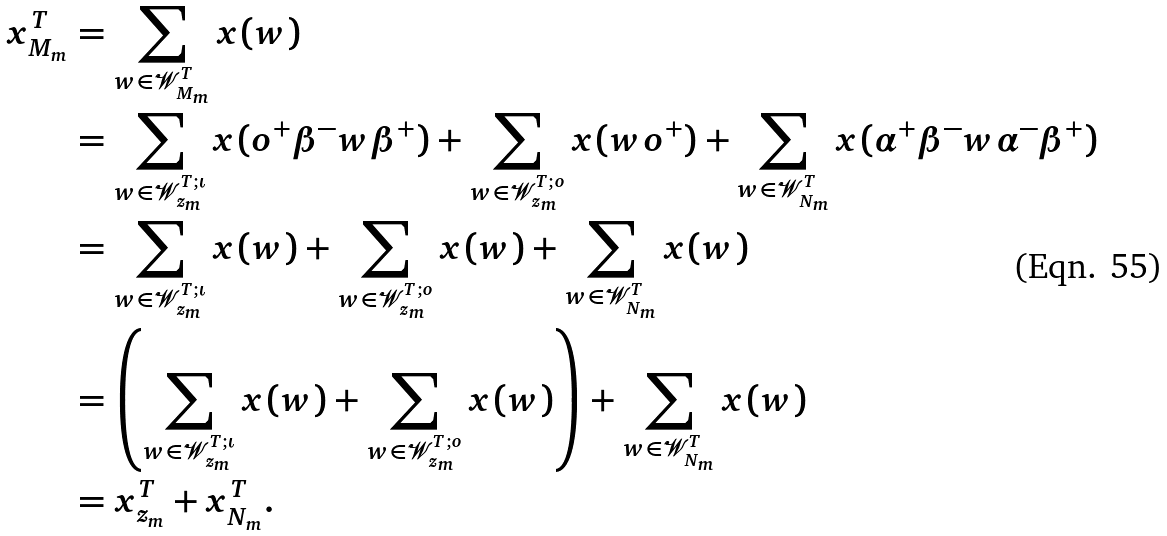Convert formula to latex. <formula><loc_0><loc_0><loc_500><loc_500>x ^ { T } _ { M _ { m } } & = \sum _ { w \in \mathcal { W } ^ { T } _ { M _ { m } } } x ( w ) \\ & = \sum _ { w \in \mathcal { W } ^ { T ; \iota } _ { z _ { m } } } x ( o ^ { + } \beta ^ { - } w \beta ^ { + } ) + \sum _ { w \in \mathcal { W } ^ { T ; o } _ { z _ { m } } } x ( w o ^ { + } ) + \sum _ { w \in \mathcal { W } ^ { T } _ { N _ { m } } } x ( \alpha ^ { + } \beta ^ { - } w \alpha ^ { - } \beta ^ { + } ) \\ & = \sum _ { w \in \mathcal { W } ^ { T ; \iota } _ { z _ { m } } } x ( w ) + \sum _ { w \in \mathcal { W } ^ { T ; o } _ { z _ { m } } } x ( w ) + \sum _ { w \in \mathcal { W } ^ { T } _ { N _ { m } } } x ( w ) \\ & = \left ( \sum _ { w \in \mathcal { W } ^ { T ; \iota } _ { z _ { m } } } x ( w ) + \sum _ { w \in \mathcal { W } ^ { T ; o } _ { z _ { m } } } x ( w ) \right ) + \sum _ { w \in \mathcal { W } ^ { T } _ { N _ { m } } } x ( w ) \\ & = x ^ { T } _ { z _ { m } } + x ^ { T } _ { N _ { m } } .</formula> 